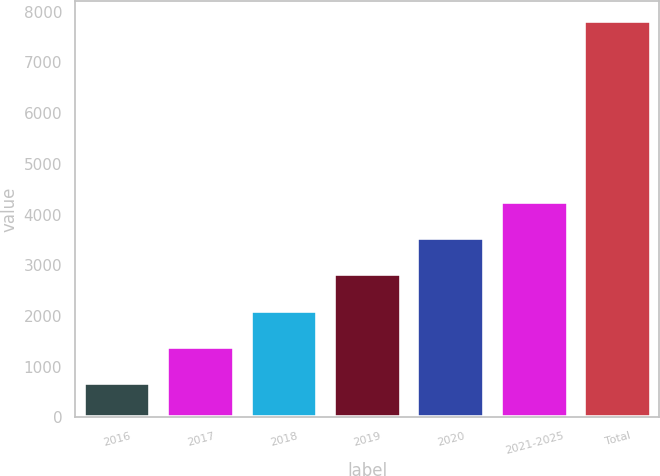Convert chart. <chart><loc_0><loc_0><loc_500><loc_500><bar_chart><fcel>2016<fcel>2017<fcel>2018<fcel>2019<fcel>2020<fcel>2021-2025<fcel>Total<nl><fcel>678<fcel>1392.1<fcel>2106.2<fcel>2820.3<fcel>3534.4<fcel>4248.5<fcel>7819<nl></chart> 